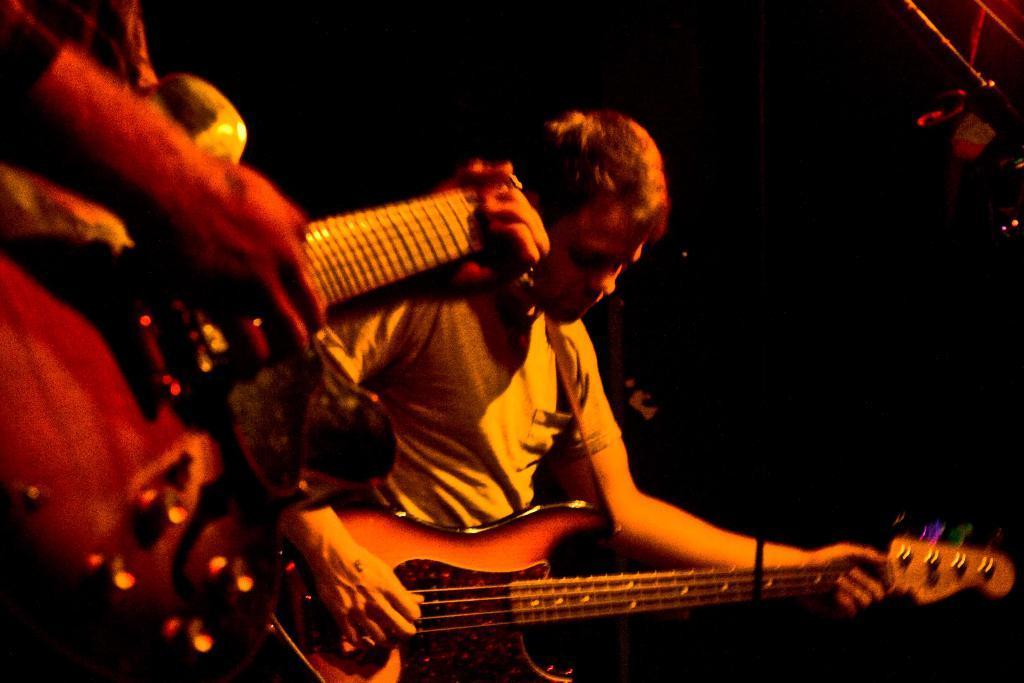Please provide a concise description of this image. In this picture of person is holding the guitar with his left and playing the guitar with his right hand and there is also an other person holding the guitar with his left and playing the guitar with his right hand. 